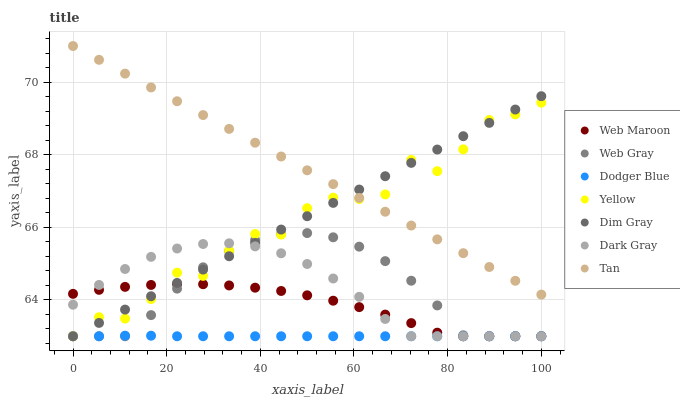Does Dodger Blue have the minimum area under the curve?
Answer yes or no. Yes. Does Tan have the maximum area under the curve?
Answer yes or no. Yes. Does Web Maroon have the minimum area under the curve?
Answer yes or no. No. Does Web Maroon have the maximum area under the curve?
Answer yes or no. No. Is Tan the smoothest?
Answer yes or no. Yes. Is Yellow the roughest?
Answer yes or no. Yes. Is Web Maroon the smoothest?
Answer yes or no. No. Is Web Maroon the roughest?
Answer yes or no. No. Does Dim Gray have the lowest value?
Answer yes or no. Yes. Does Tan have the lowest value?
Answer yes or no. No. Does Tan have the highest value?
Answer yes or no. Yes. Does Web Maroon have the highest value?
Answer yes or no. No. Is Web Maroon less than Tan?
Answer yes or no. Yes. Is Tan greater than Dark Gray?
Answer yes or no. Yes. Does Dim Gray intersect Tan?
Answer yes or no. Yes. Is Dim Gray less than Tan?
Answer yes or no. No. Is Dim Gray greater than Tan?
Answer yes or no. No. Does Web Maroon intersect Tan?
Answer yes or no. No. 